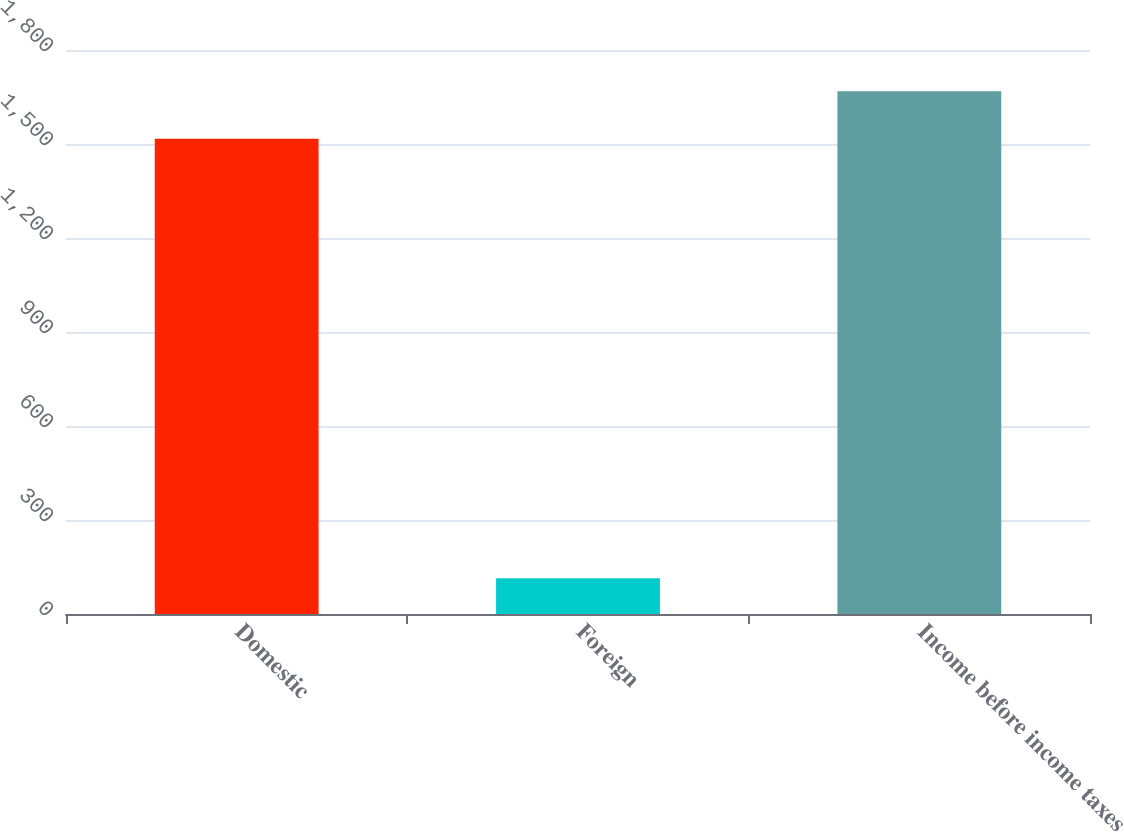Convert chart. <chart><loc_0><loc_0><loc_500><loc_500><bar_chart><fcel>Domestic<fcel>Foreign<fcel>Income before income taxes<nl><fcel>1517<fcel>114<fcel>1668.7<nl></chart> 